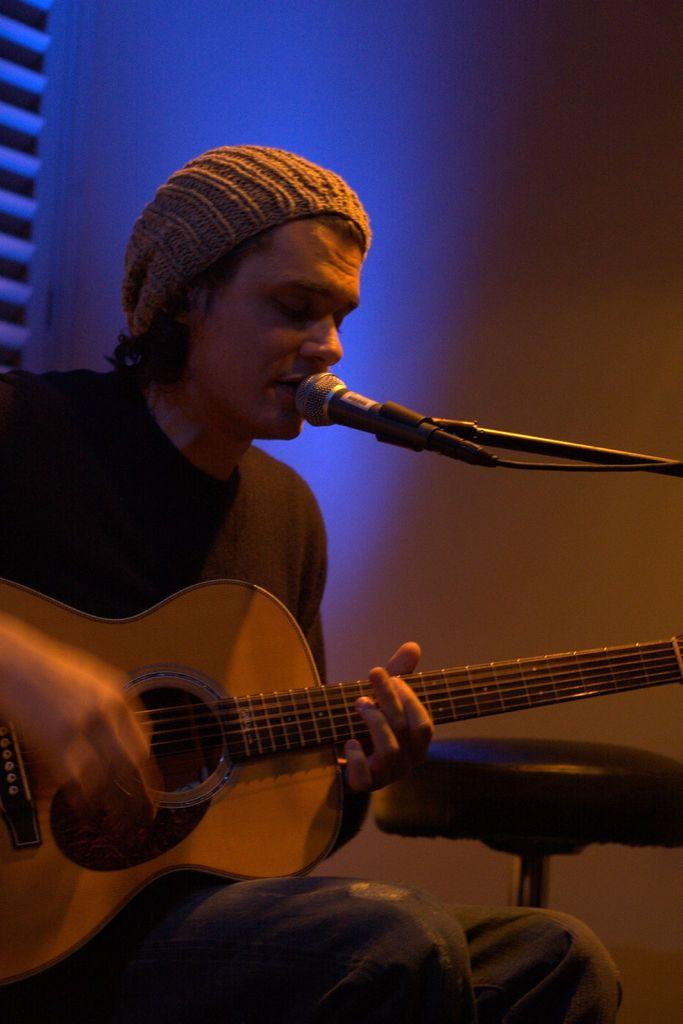What is the man in the image doing? The man is playing a guitar. What object is in front of the man's mouth? There is a microphone in front of the man's mouth. What type of linen is draped over the guitar in the image? There is no linen draped over the guitar in the image. What season is depicted in the image? The provided facts do not give any information about the season or weather in the image. 